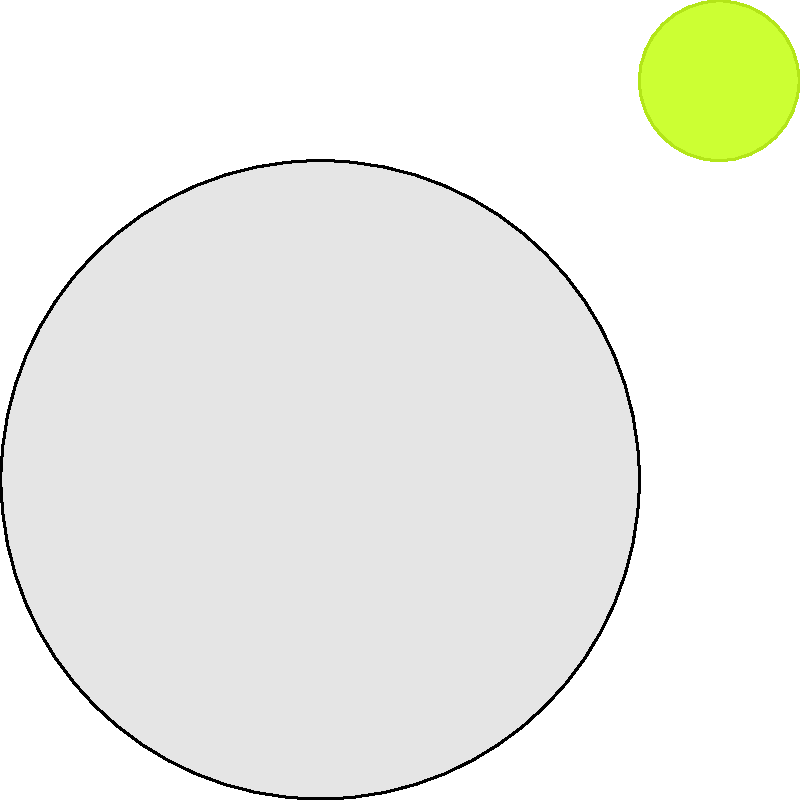As a dietitian involved in menu planning, you're teaching clients about portion control. Using the image provided, which shows a plate, a tennis ball for scale, and a piece of chicken breast, estimate the approximate weight of the chicken breast portion. Assume the plate is a standard 9-inch dinner plate. To estimate the weight of the chicken breast, we'll follow these steps:

1. Use the tennis ball as a reference:
   - A tennis ball is approximately 2.5 inches in diameter.
   - In the image, the tennis ball is about 1/4 the diameter of the plate.

2. Estimate the size of the chicken breast:
   - The chicken breast appears to be about 1.5 times the size of the tennis ball in length.
   - Its width is roughly equal to the tennis ball's diameter.

3. Calculate the approximate dimensions:
   - Length: $2.5 \text{ inches} \times 1.5 = 3.75 \text{ inches}$
   - Width: $2.5 \text{ inches}$
   - Thickness (estimated): about 0.5 inches

4. Estimate the volume:
   $V = 3.75 \text{ inches} \times 2.5 \text{ inches} \times 0.5 \text{ inches} = 4.69 \text{ cubic inches}$

5. Convert volume to weight:
   - Chicken breast density is approximately 1.06 g/cm³
   - $4.69 \text{ in}^3 \approx 76.85 \text{ cm}^3$
   - $76.85 \text{ cm}^3 \times 1.06 \text{ g/cm}^3 = 81.46 \text{ g}$

6. Convert to ounces:
   $81.46 \text{ g} \approx 2.87 \text{ oz}$

Therefore, the chicken breast portion is approximately 3 ounces.
Answer: 3 ounces 